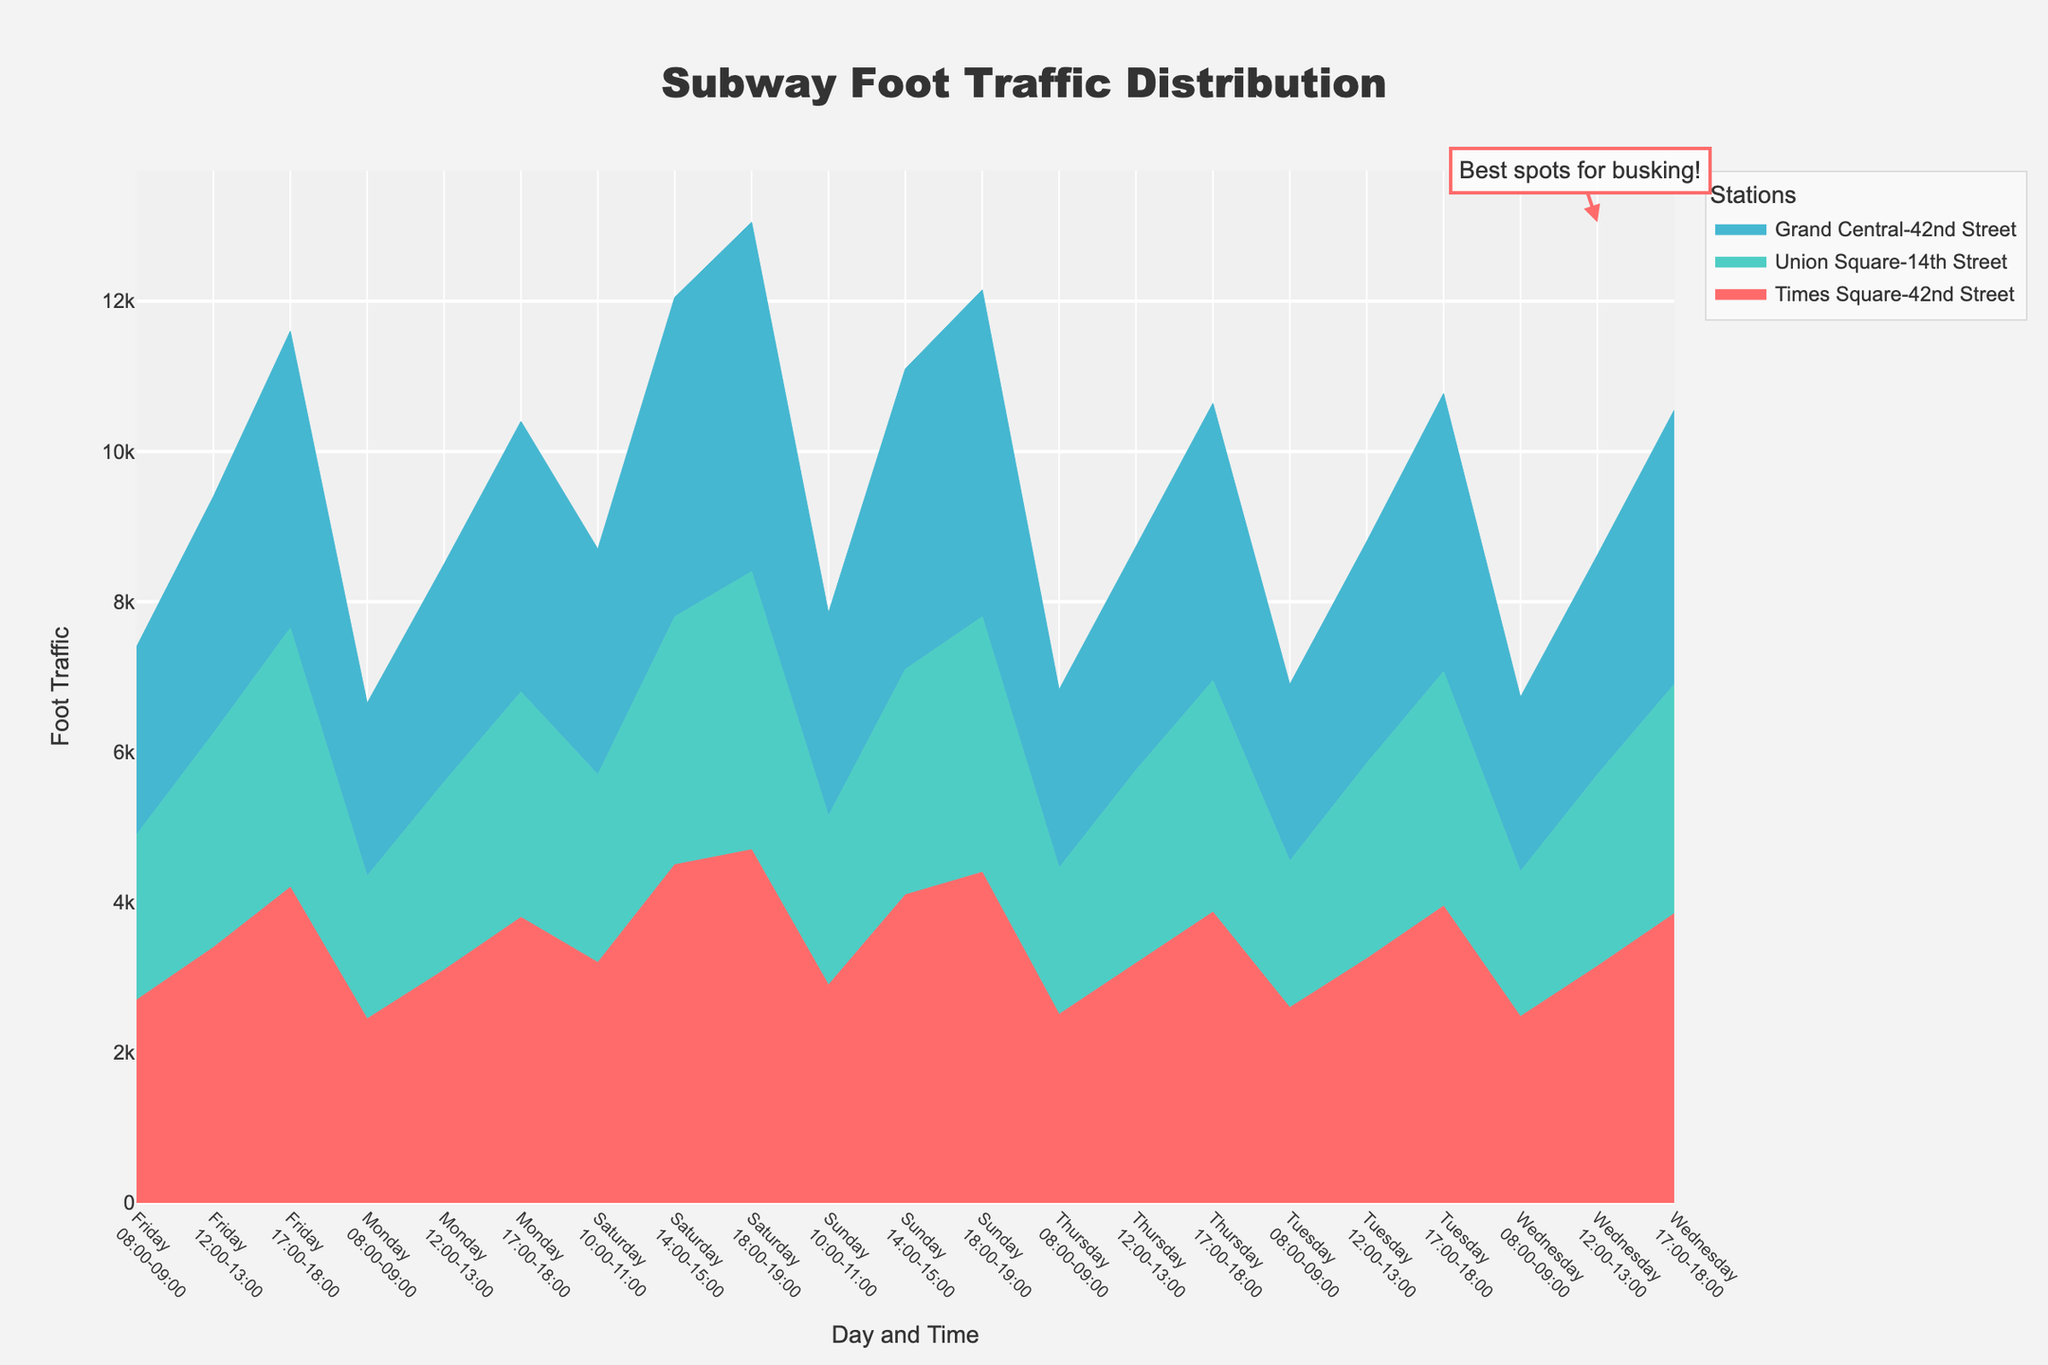What's the title of the chart? The title is typically displayed prominently at the top of the chart. It reads "Subway Foot Traffic Distribution".
Answer: Subway Foot Traffic Distribution Which station appears to have the highest foot traffic during weekdays between 17:00-18:00? For each day, the area representing each station’s foot traffic during the 17:00-18:00 timeframe should be inspected. Times Square-42nd Street consistently shows the highest peak in the stack of the area chart.
Answer: Times Square-42nd Street What is the overall trend of foot traffic on weekends compared to weekdays? Inspect the filled areas representing weekend days (Saturday and Sunday) as compared to the other days of the week. Generally, the foot traffic is higher on weekends, especially during the afternoons and evenings.
Answer: Higher on weekends Which station shows a noticeable increase in foot traffic on Friday compared to other weekdays? Compare the area sizes representing Friday’s foot traffic for each station. Times Square-42nd Street shows a noticeable increase in foot traffic on Friday, particularly during the evening.
Answer: Times Square-42nd Street How does the foot traffic at Union Square-14th Street at 12:00-13:00 vary from Monday to Friday? Inspect the stacked areas for Union Square-14th Street during 12:00-13:00 for each weekday. The foot traffic increases gradually from Monday to Friday.
Answer: Gradual increase What's the combined foot traffic for Times Square-42nd Street and Grand Central-42nd Street at 08:00-09:00 on Monday? Sum the foot traffic values of both stations at Monday 08:00-09:00 from the chart. Times Square-42nd Street has 2450 and Grand Central-42nd Street has 2300. Combined, this is 2450 + 2300 = 4750.
Answer: 4750 How does the foot traffic on Sunday mornings at Times Square-42nd Street compare to Saturday mornings? Examine the areas for the timeslot of 10:00-11:00 on both Saturday and Sunday for Times Square-42nd Street. The foot traffic on Sunday morning is slightly lower than Saturday morning.
Answer: Lower on Sunday What day and time saw the highest overall foot traffic? Look for the highest peak across the entire area chart. Saturday from 18:00-19:00 stands out as having the highest overall foot traffic.
Answer: Saturday 18:00-19:00 Which station has the least variability in foot traffic across the week? Evaluate the fluctuations in the stacked areas across different days for each station. Union Square-14th Street shows relatively stable and less variable foot traffic patterns.
Answer: Union Square-14th Street What can be inferred about the best times for busking based on the chart? Analyze the areas with the highest foot traffic as they are likely to have more passersby. Evenings on weekdays and afternoons to early evenings on weekends present the best opportunities for busking.
Answer: Evenings and weekend afternoons 